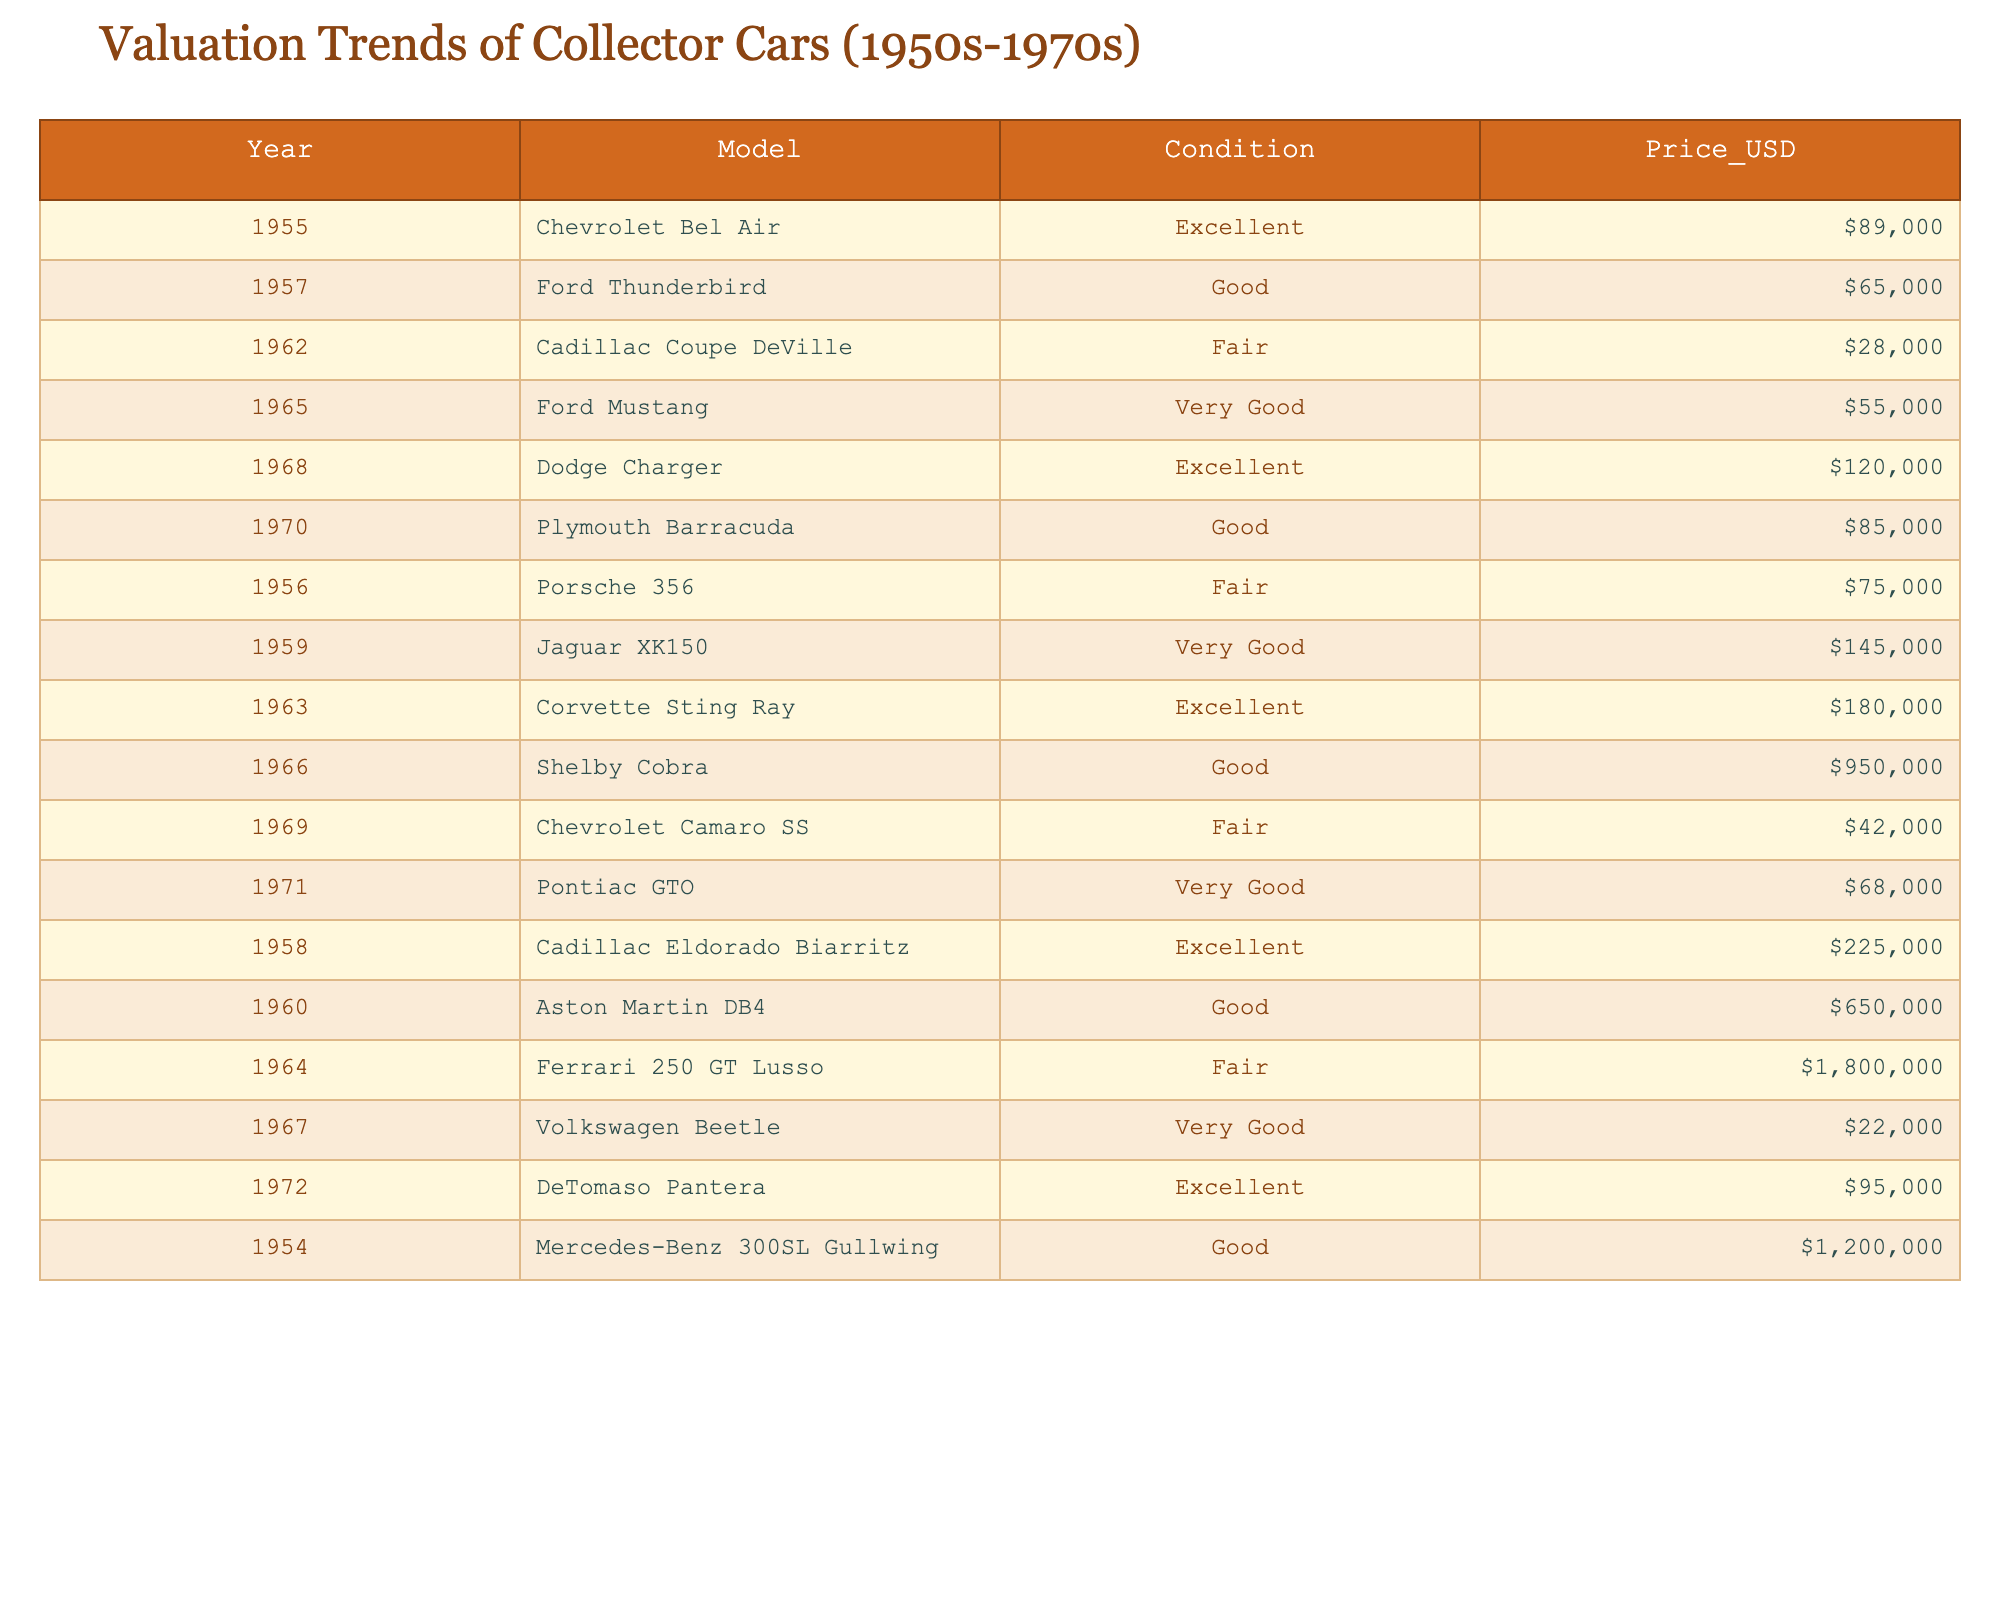What is the highest-priced car in the table? By examining the "Price_USD" column, we can find the maximum value, which is $1,800,000 for the Ferrari 250 GT Lusso.
Answer: $1,800,000 How many cars were listed as being in "Excellent" condition? We can count the rows where the "Condition" is labeled as "Excellent", which appears 5 times in the table.
Answer: 5 What is the average price of cars labeled "Good"? First, we identify the prices of the cars in "Good" condition: $65,000 (Ford Thunderbird), $85,000 (Plymouth Barracuda), $650,000 (Aston Martin DB4), and $1,200,000 (Mercedes-Benz 300SL Gullwing). The total is $1,000,000 and dividing this by 4 gives us an average of $250,000.
Answer: $250,000 Did any car from the 1950s have a price exceeding $200,000? Looking through the prices of cars from the 1950s, the highest is $225,000 for the Cadillac Eldorado Biarritz, which exceeds $200,000.
Answer: Yes Which model from the 1960s had the highest price? We check the 1960s models: Ford Mustang ($55,000), Corvette Sting Ray ($180,000), and Volkswagen Beetle ($22,000). The Corvette Sting Ray at $180,000 is the highest-priced model from this decade.
Answer: Corvette Sting Ray What is the total price of all the "Fair" condition cars? The prices of "Fair" condition cars are $28,000 (Cadillac Coupe DeVille), $75,000 (Porsche 356), $180,000 (Ferrari 250 GT Lusso), and $42,000 (Chevrolet Camaro SS). Adding these prices gives $325,000.
Answer: $325,000 Which decade had the most cars listed in "Very Good" condition? By reviewing the table, there are two cars in "Very Good" condition from the 1960s (Jaguar XK150 and Corvette Sting Ray) and one from the 1970s (Pontiac GTO). So the 1960s has the most with 2 cars.
Answer: 1960s Is there a car in the table that has a price below $30,000? Looking at the prices, the lowest is $28,000 for the Cadillac Coupe DeVille, which is below $30,000.
Answer: Yes What is the price difference between the most expensive car and the least expensive car in the table? The most expensive car is the Ferrari 250 GT Lusso at $1,800,000, and the least expensive is the Dodge Charger at $120,000. The price difference is $1,800,000 - $120,000 = $1,680,000.
Answer: $1,680,000 Which model has the highest valuation trend from the 1970s? In the 1970s, we have the DeTomaso Pantera at $95,000 and Pontiac GTO at $68,000. The DeTomaso Pantera is priced higher, marking the highest trend for that decade.
Answer: DeTomaso Pantera 